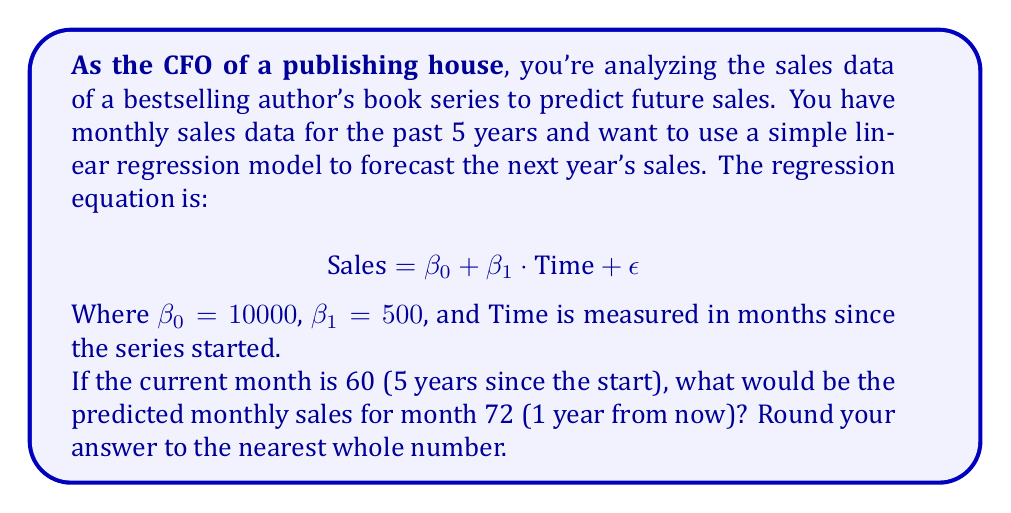Can you answer this question? To solve this problem, we'll follow these steps:

1. Understand the linear regression model:
   The model is given by the equation $\text{Sales} = \beta_0 + \beta_1 \cdot \text{Time} + \epsilon$
   Where $\beta_0 = 10000$ (y-intercept) and $\beta_1 = 500$ (slope)

2. Identify the time point we're predicting:
   We want to predict sales for month 72, which is 12 months (1 year) from the current month 60.

3. Plug the values into the equation:
   $\text{Sales} = 10000 + 500 \cdot 72$

4. Calculate the result:
   $\text{Sales} = 10000 + 36000 = 46000$

5. Round to the nearest whole number:
   The result is already a whole number, so no rounding is necessary.

This linear model assumes a constant increase in sales over time, which may not always be realistic for book sales. As a cautious CFO, it's important to consider other factors that might affect sales and potentially use more complex models for more accurate predictions.
Answer: 46000 